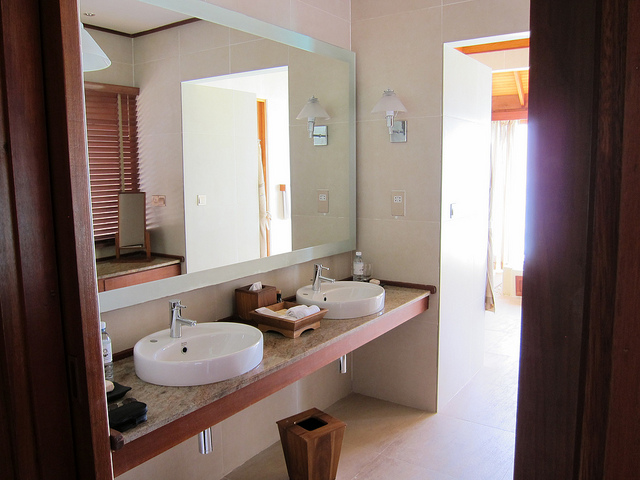Can you describe any decorative elements or styles visible in the bathroom? The bathroom exhibits a modern and minimalist style, characterized by neutral colors and clean lines. Attention to detail is evident in the choice of mounted lamps and the wooden frame around the mirror, adding a touch of warmth and elegance to the space. 